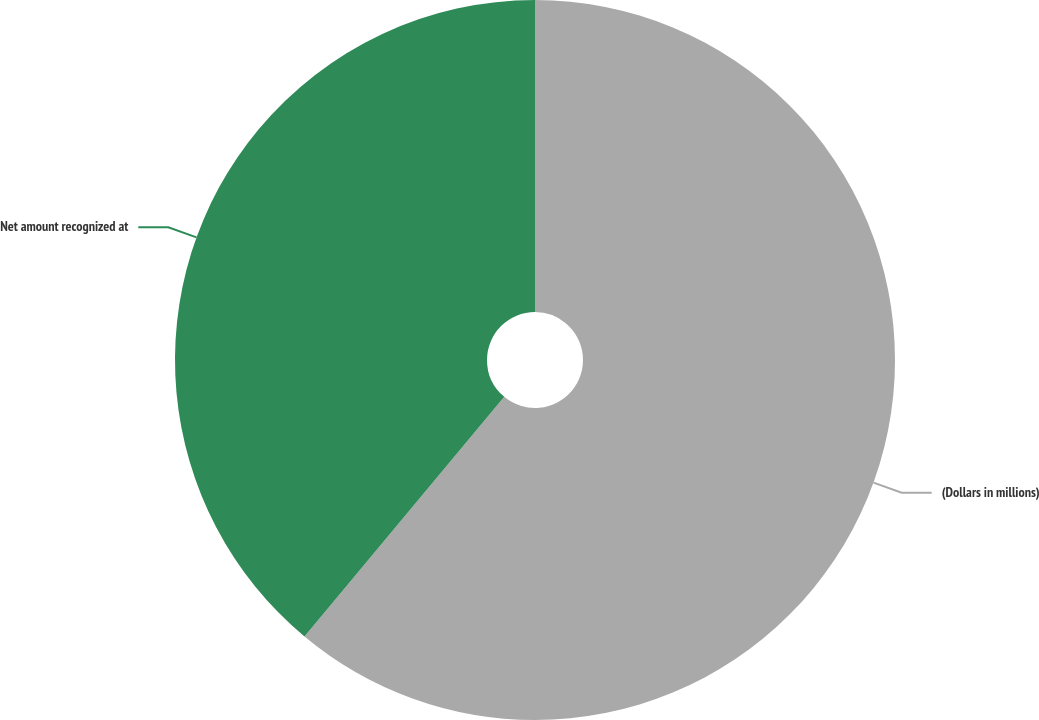Convert chart. <chart><loc_0><loc_0><loc_500><loc_500><pie_chart><fcel>(Dollars in millions)<fcel>Net amount recognized at<nl><fcel>61.06%<fcel>38.94%<nl></chart> 